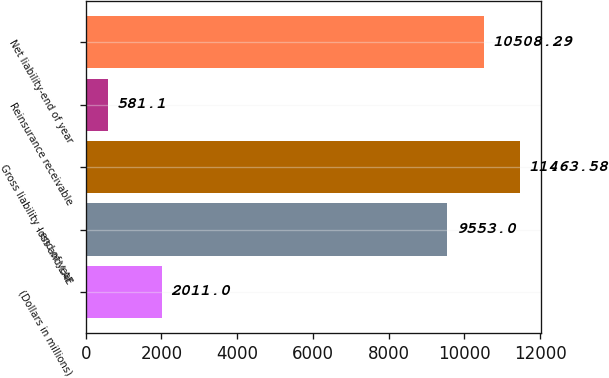Convert chart to OTSL. <chart><loc_0><loc_0><loc_500><loc_500><bar_chart><fcel>(Dollars in millions)<fcel>loss and LAE<fcel>Gross liability - end of year<fcel>Reinsurance receivable<fcel>Net liability-end of year<nl><fcel>2011<fcel>9553<fcel>11463.6<fcel>581.1<fcel>10508.3<nl></chart> 